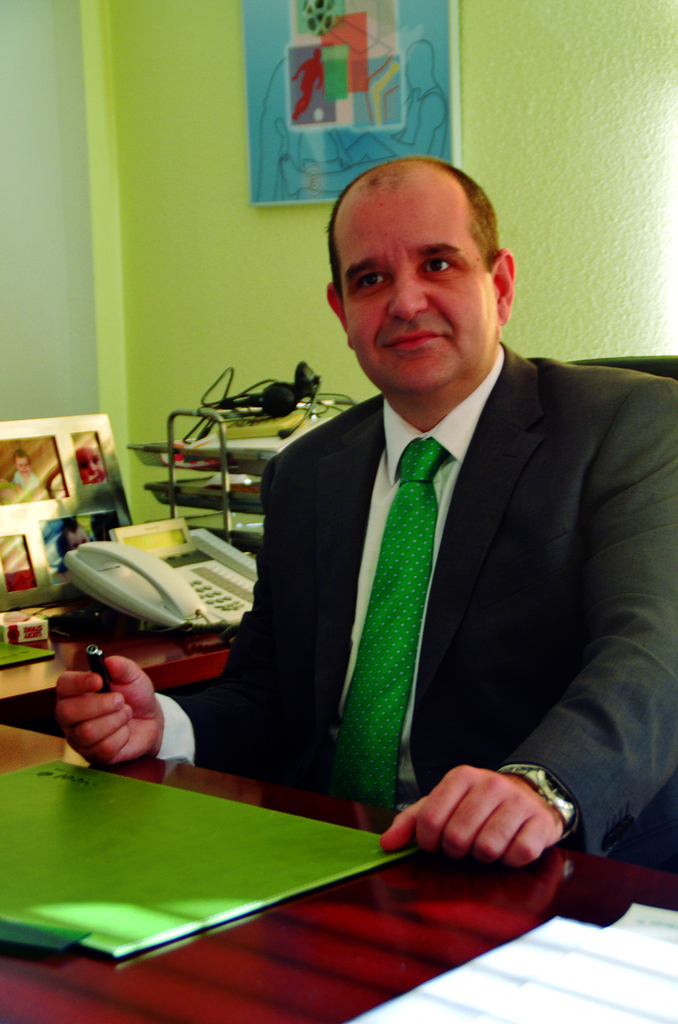In one or two sentences, can you explain what this image depicts? In this image, we can see a person holding an object and sitting on the chair in front of the table. This table contains colored cardboard plank. There is a telephone, photo frame and rack on the left side of the image. There is a wall art at the top of the image. 